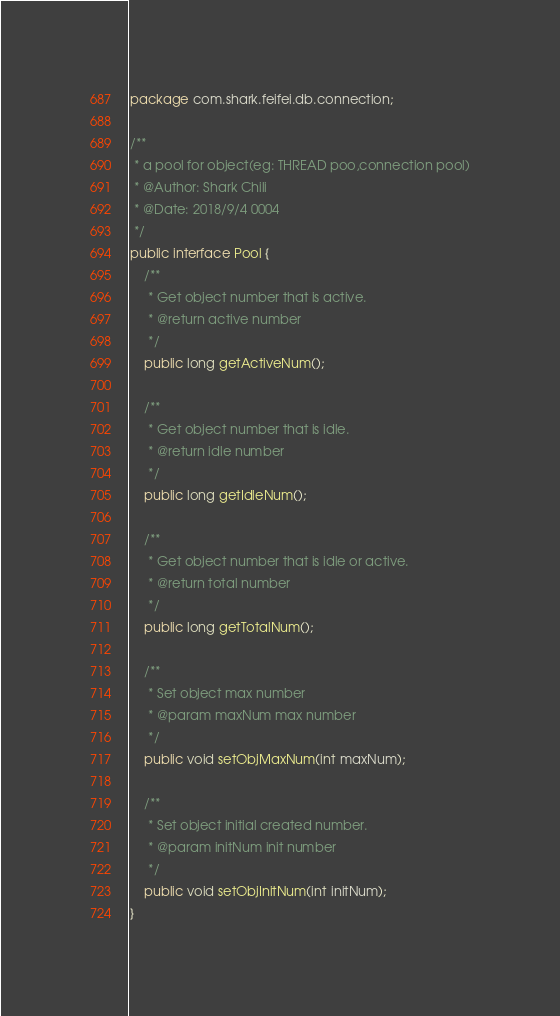Convert code to text. <code><loc_0><loc_0><loc_500><loc_500><_Java_>package com.shark.feifei.db.connection;

/**
 * a pool for object(eg: THREAD poo,connection pool)
 * @Author: Shark Chili
 * @Date: 2018/9/4 0004
 */
public interface Pool {
	/**
	 * Get object number that is active.
	 * @return active number
	 */
	public long getActiveNum();

	/**
	 * Get object number that is idle.
	 * @return idle number
	 */
	public long getIdleNum();

	/**
	 * Get object number that is idle or active.
	 * @return total number
	 */
	public long getTotalNum();

	/**
	 * Set object max number
	 * @param maxNum max number
	 */
	public void setObjMaxNum(int maxNum);

	/**
	 * Set object initial created number.
	 * @param initNum init number
	 */
	public void setObjInitNum(int initNum);
}
</code> 